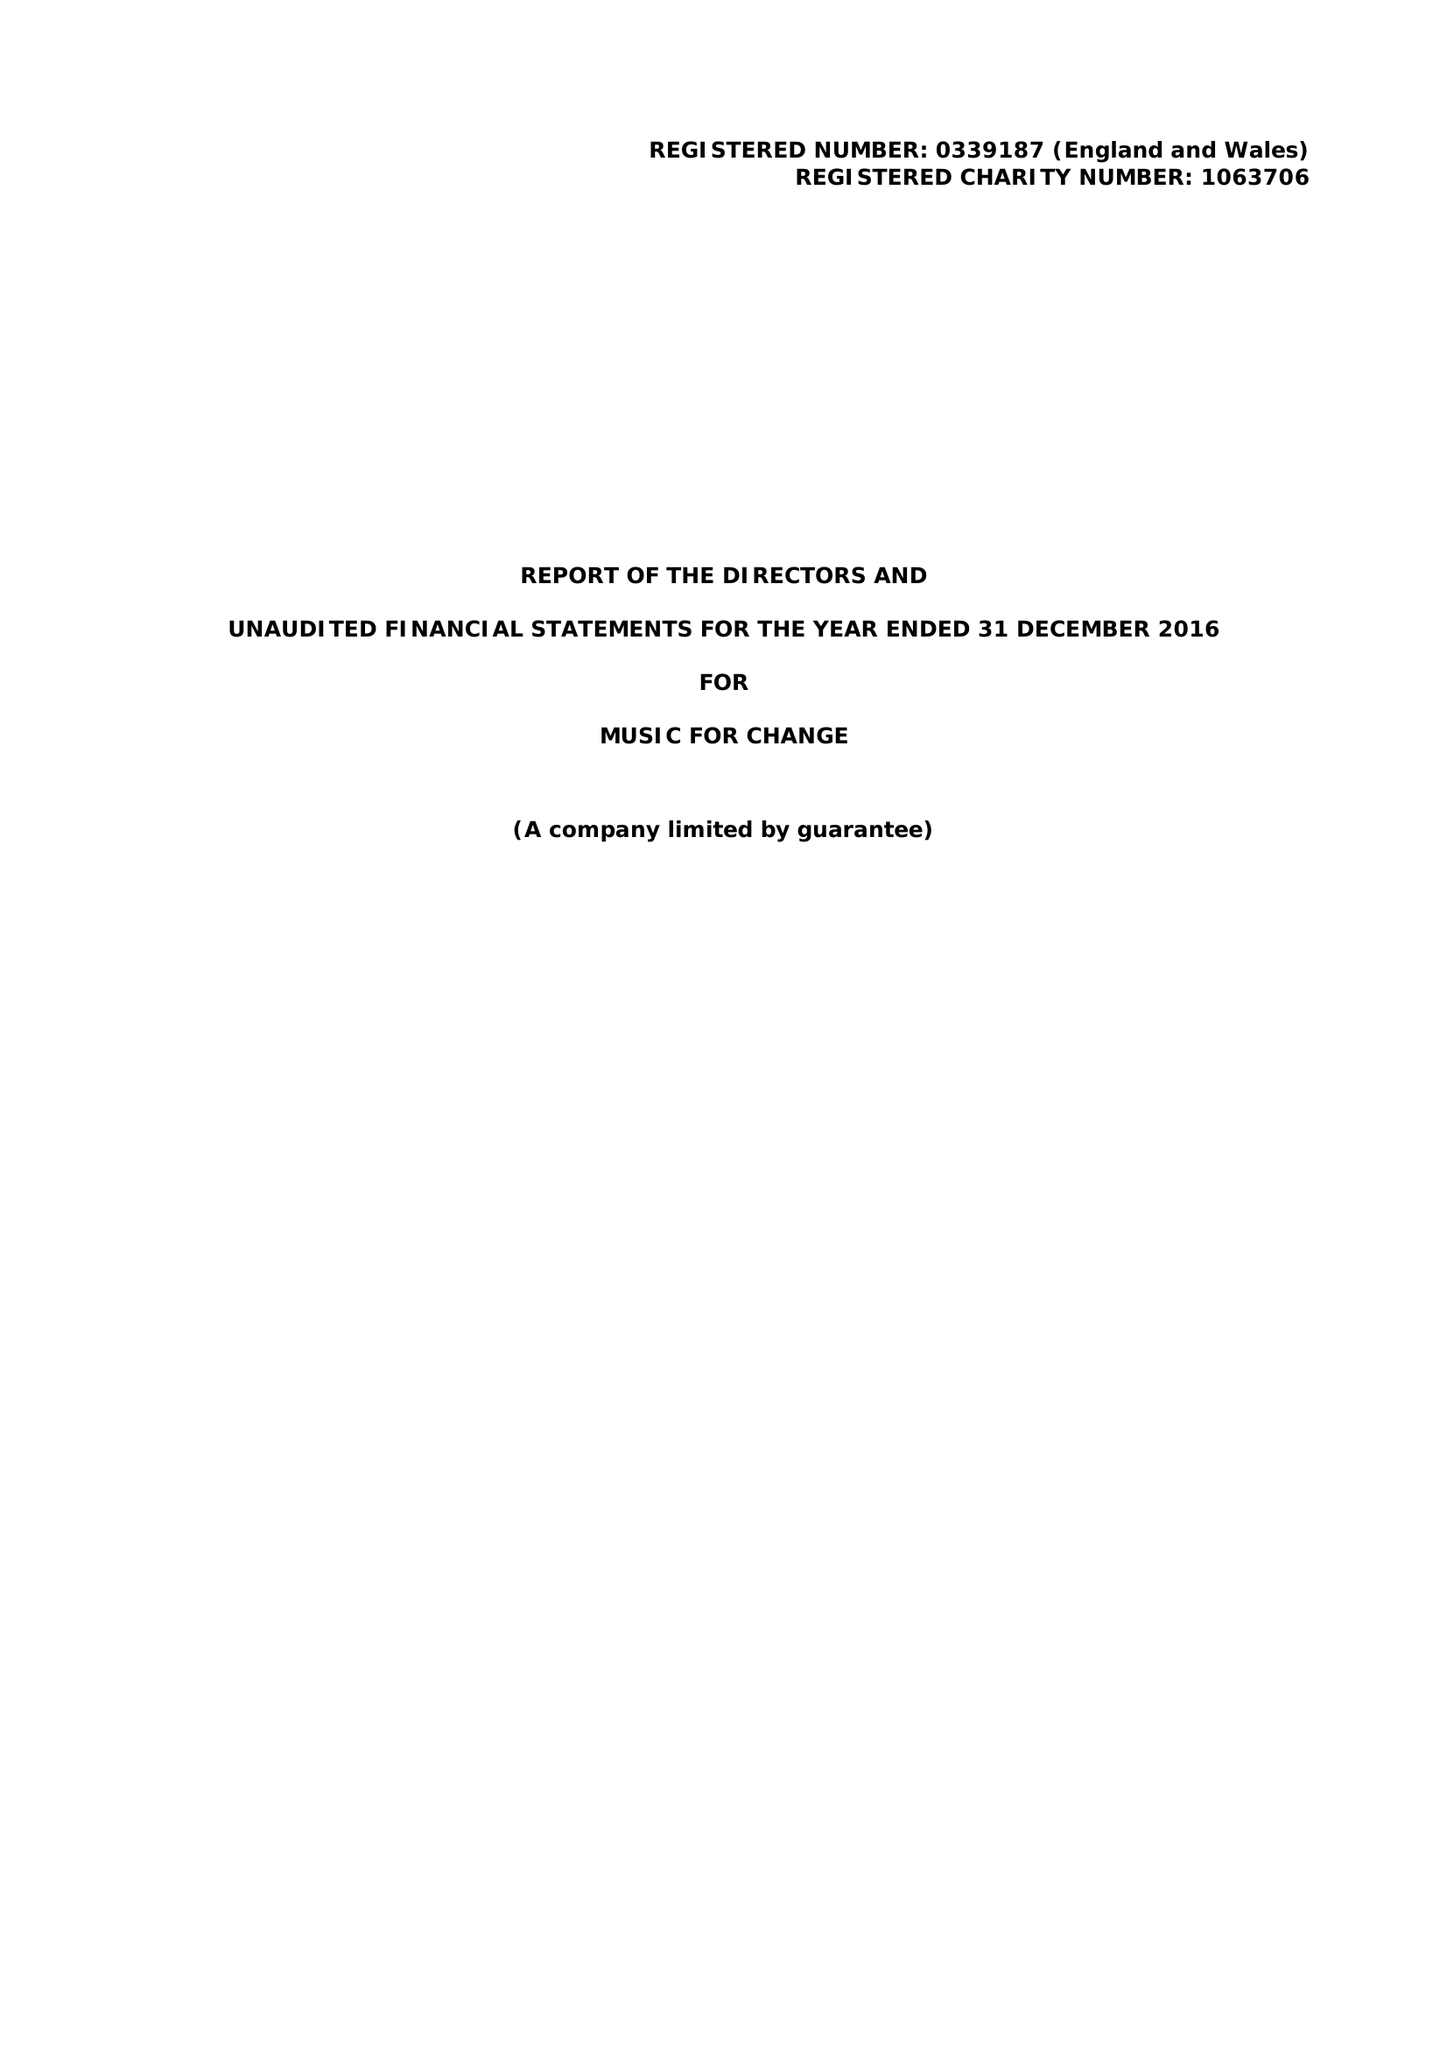What is the value for the report_date?
Answer the question using a single word or phrase. 2016-12-31 